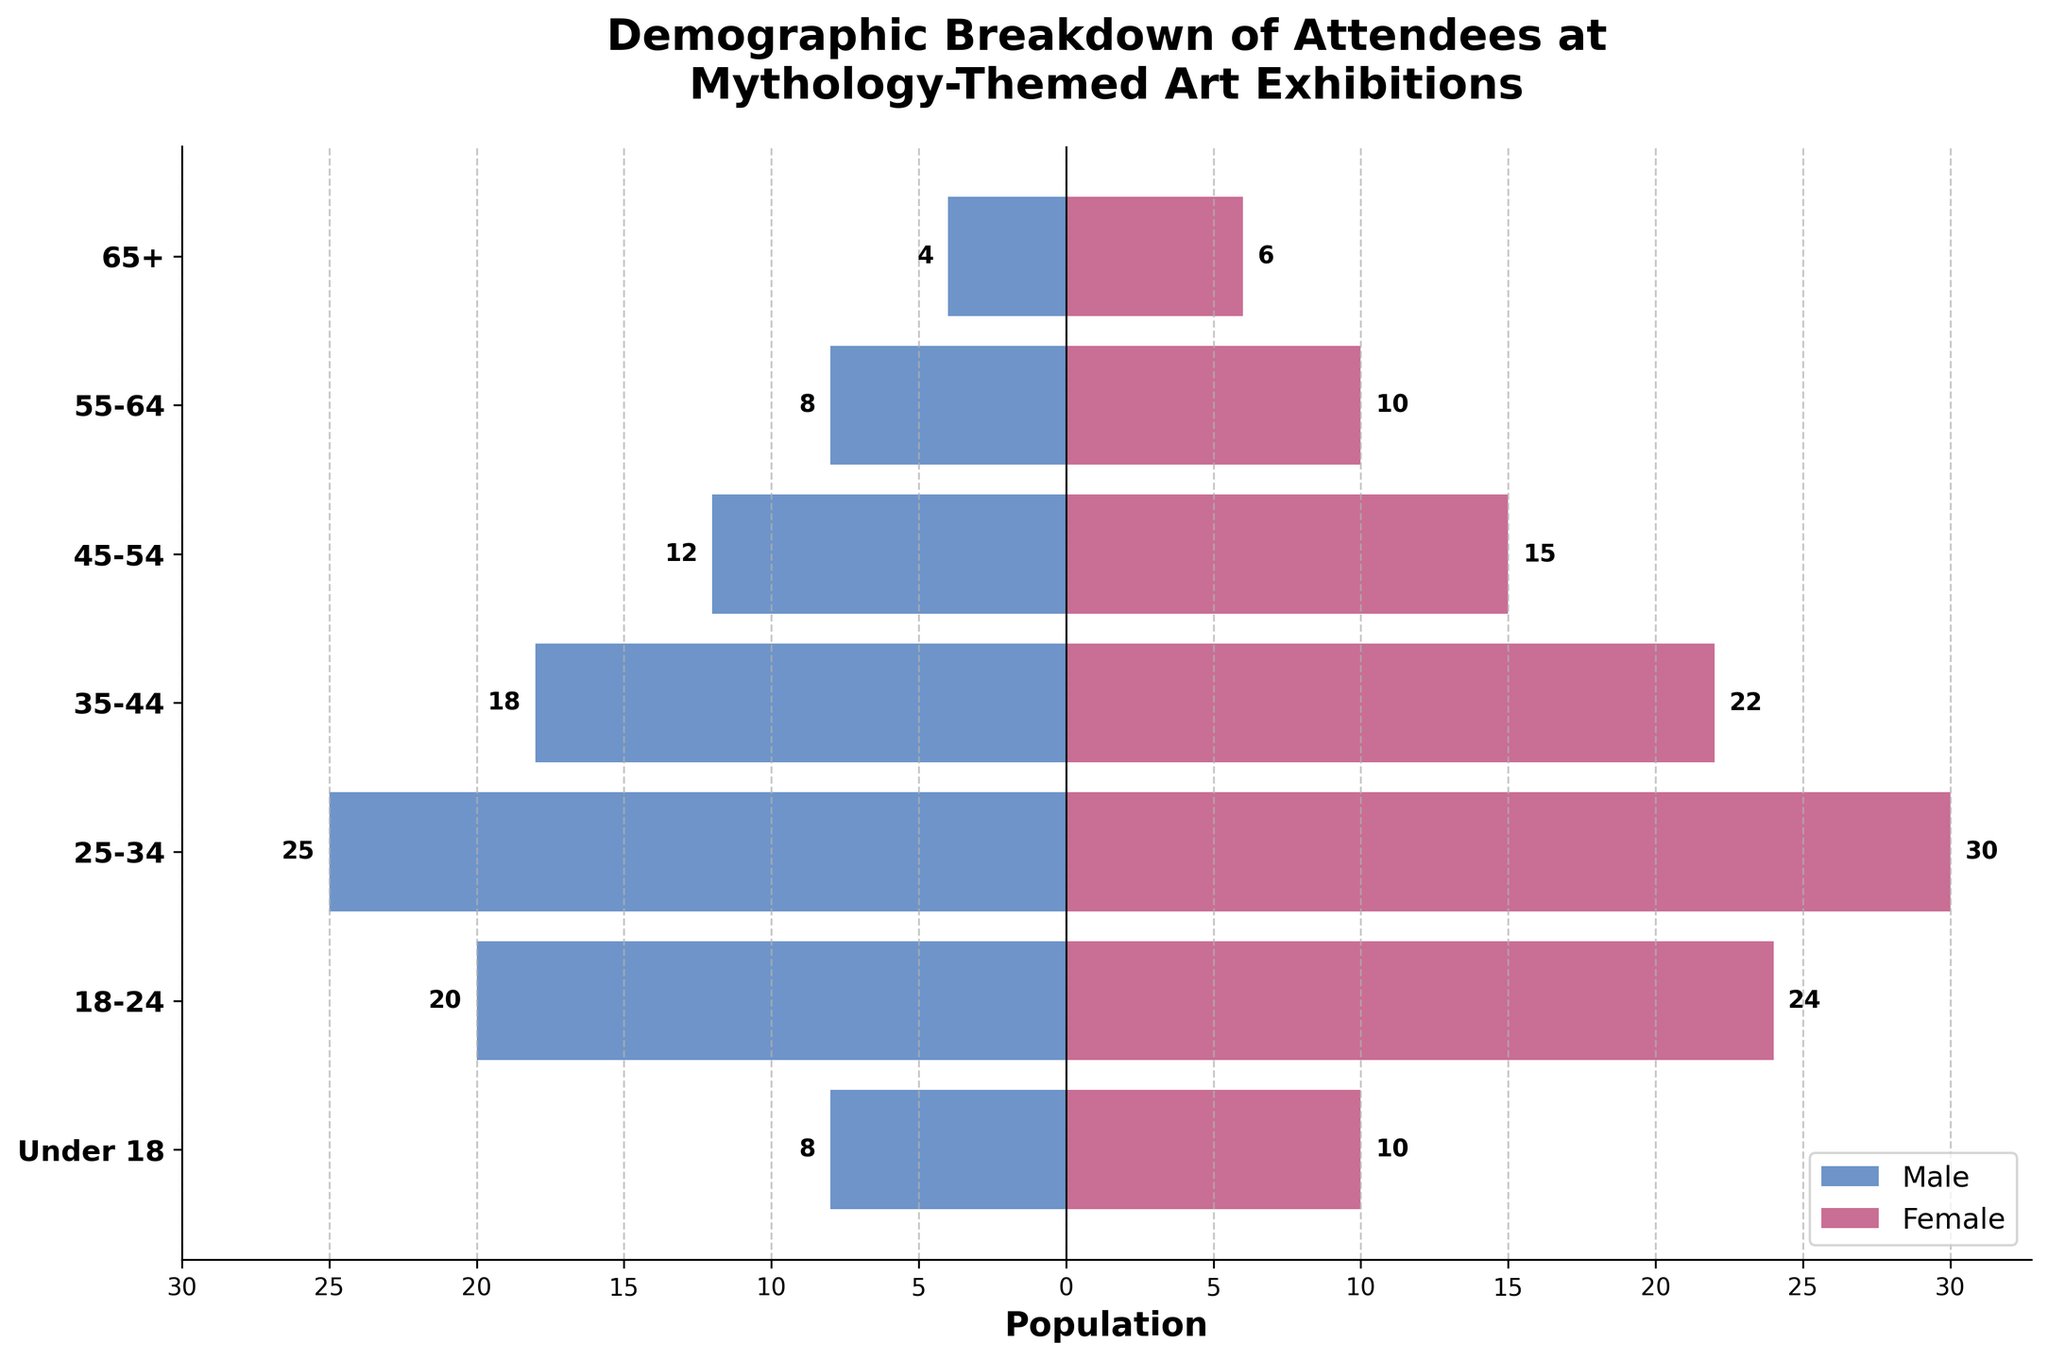What is the title of the figure? The title is usually located at the top of the figure. In this case, it's provided directly in the illustration design.
Answer: Demographic Breakdown of Attendees at Mythology-Themed Art Exhibitions Which age group has the highest number of female attendees? To determine this, look at the bar lengths for the female attendees (bars to the right). The 25-34 age group has the longest bar.
Answer: 25-34 How many more male attendees are there aged 25-34 compared to those aged 18-24? Locate the bars for male attendees in the 25-34 and 18-24 age groups. The lengths are 25 and 20, respectively. Subtract the number of 18-24 attendees from 25-34 attendees: 25 - 20.
Answer: 5 What is the total number of attendees under the age of 18? Add the male and female attendees in the 'Under 18' age group: 8 (male) + 10 (female).
Answer: 18 Which gender has more attendees aged 55-64, and by how many? Compare the male and female bars for the 55-64 age group. Males have a length of 8, and females have a length of 10. The difference is 10 - 8.
Answer: Female, by 2 How many attendees are there in the 45-54 age group? Add the numbers of male and female attendees in the 45-54 age group: 12 (male) + 15 (female).
Answer: 27 Which age group has the closest ratio of male to female attendees? To find this, compare the length of the male and female bars for each age group. The 65+ age group has male: 4 and female: 6, which is closest in proportion.
Answer: 65+ Which age group has the smallest combined total of attendees? To find this, add the male and female numbers for each age group and then find the smallest sum. The 65+ age group has the smallest total: 4 (male) + 6 (female).
Answer: 65+, with 10 What is the ratio of female to male attendees in the 35-44 age group? Divide the number of female attendees by the number of male attendees in the 35-44 age group: 22 (female) / 18 (male).
Answer: 1.22 How many attendees are between 18-34 years old? Add the male and female attendees in the 18-24 and 25-34 age groups: (20 + 24) + (25 + 30).
Answer: 99 